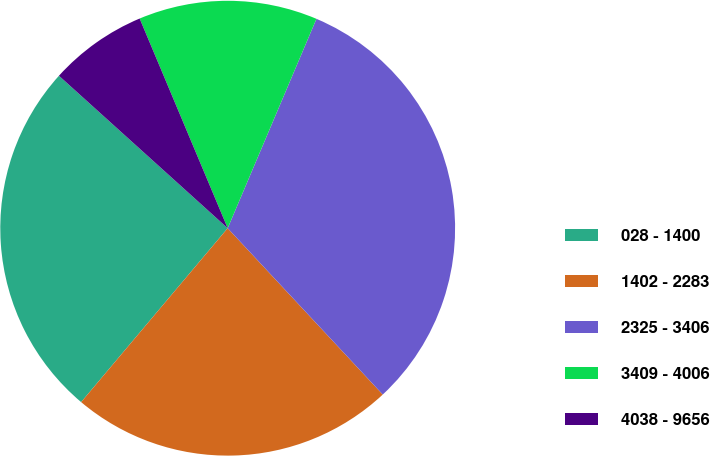<chart> <loc_0><loc_0><loc_500><loc_500><pie_chart><fcel>028 - 1400<fcel>1402 - 2283<fcel>2325 - 3406<fcel>3409 - 4006<fcel>4038 - 9656<nl><fcel>25.55%<fcel>23.09%<fcel>31.68%<fcel>12.71%<fcel>6.98%<nl></chart> 